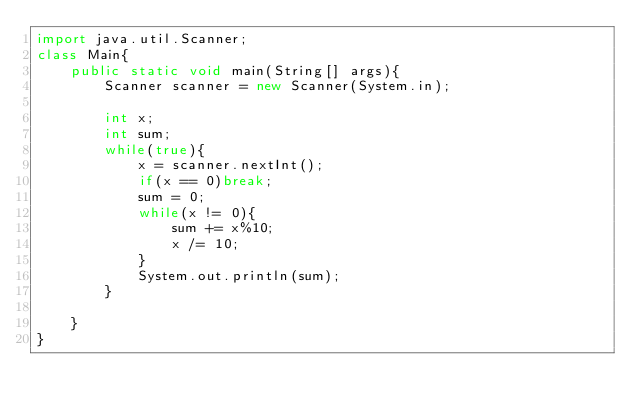Convert code to text. <code><loc_0><loc_0><loc_500><loc_500><_Java_>import java.util.Scanner;
class Main{
    public static void main(String[] args){
        Scanner scanner = new Scanner(System.in);

        int x;
        int sum;
        while(true){
            x = scanner.nextInt();
            if(x == 0)break;
            sum = 0;
            while(x != 0){
                sum += x%10;
                x /= 10;
            }
            System.out.println(sum);
        }

    }
}

</code> 